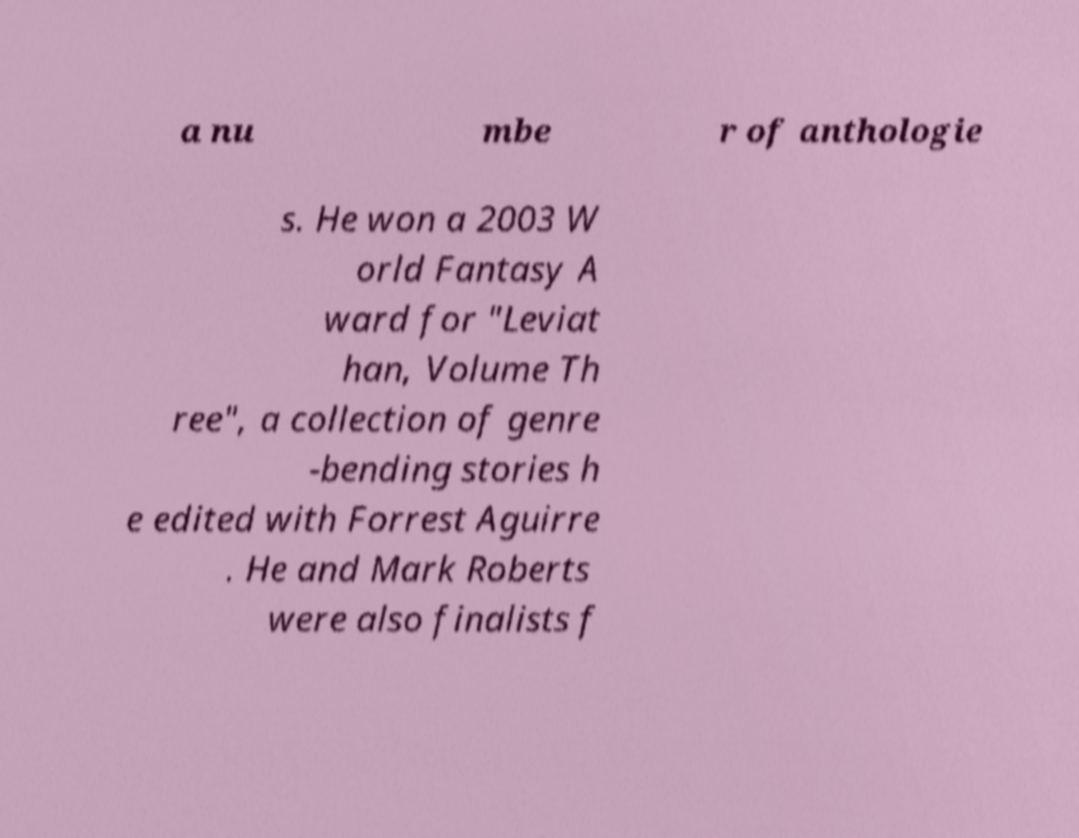What messages or text are displayed in this image? I need them in a readable, typed format. a nu mbe r of anthologie s. He won a 2003 W orld Fantasy A ward for "Leviat han, Volume Th ree", a collection of genre -bending stories h e edited with Forrest Aguirre . He and Mark Roberts were also finalists f 